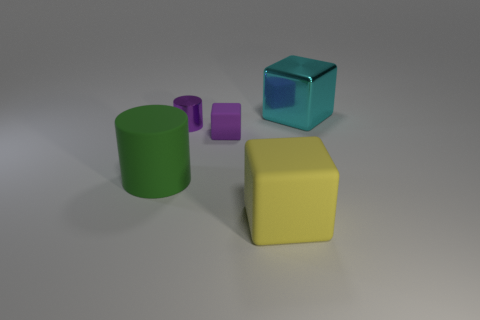What is the material of the block that is both on the left side of the large cyan shiny block and behind the green object?
Offer a very short reply. Rubber. Do the shiny thing in front of the metallic block and the large metal block have the same size?
Ensure brevity in your answer.  No. Is the number of purple metal objects that are behind the purple cube greater than the number of yellow matte objects behind the tiny purple metallic cylinder?
Your response must be concise. Yes. What is the color of the cylinder that is in front of the metallic object in front of the metallic object behind the purple cylinder?
Your response must be concise. Green. Do the matte block behind the big rubber cylinder and the rubber cylinder have the same color?
Offer a very short reply. No. What number of other things are there of the same color as the small rubber thing?
Give a very brief answer. 1. How many things are either green rubber objects or small brown objects?
Your answer should be compact. 1. What number of things are big red rubber balls or shiny things in front of the large cyan cube?
Offer a very short reply. 1. Do the purple cylinder and the large cylinder have the same material?
Give a very brief answer. No. What number of other things are there of the same material as the big cylinder
Provide a short and direct response. 2. 